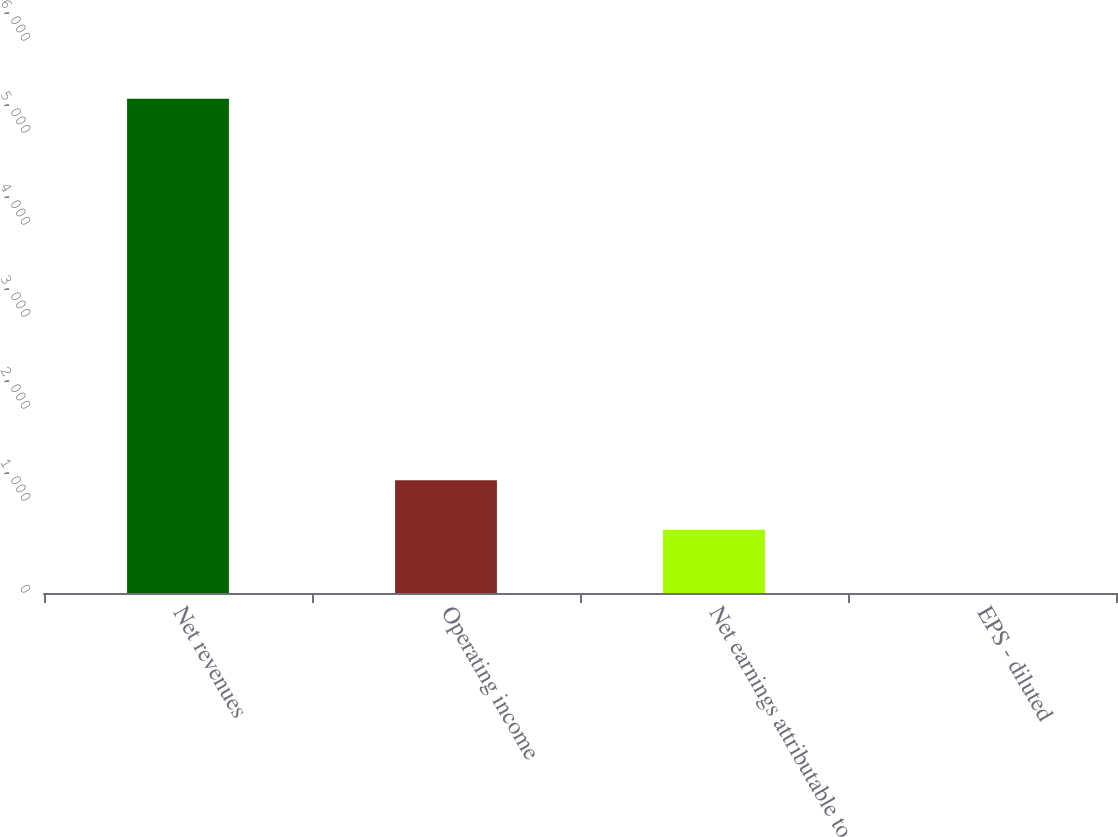Convert chart. <chart><loc_0><loc_0><loc_500><loc_500><bar_chart><fcel>Net revenues<fcel>Operating income<fcel>Net earnings attributable to<fcel>EPS - diluted<nl><fcel>5373.5<fcel>1224.9<fcel>687.6<fcel>0.46<nl></chart> 